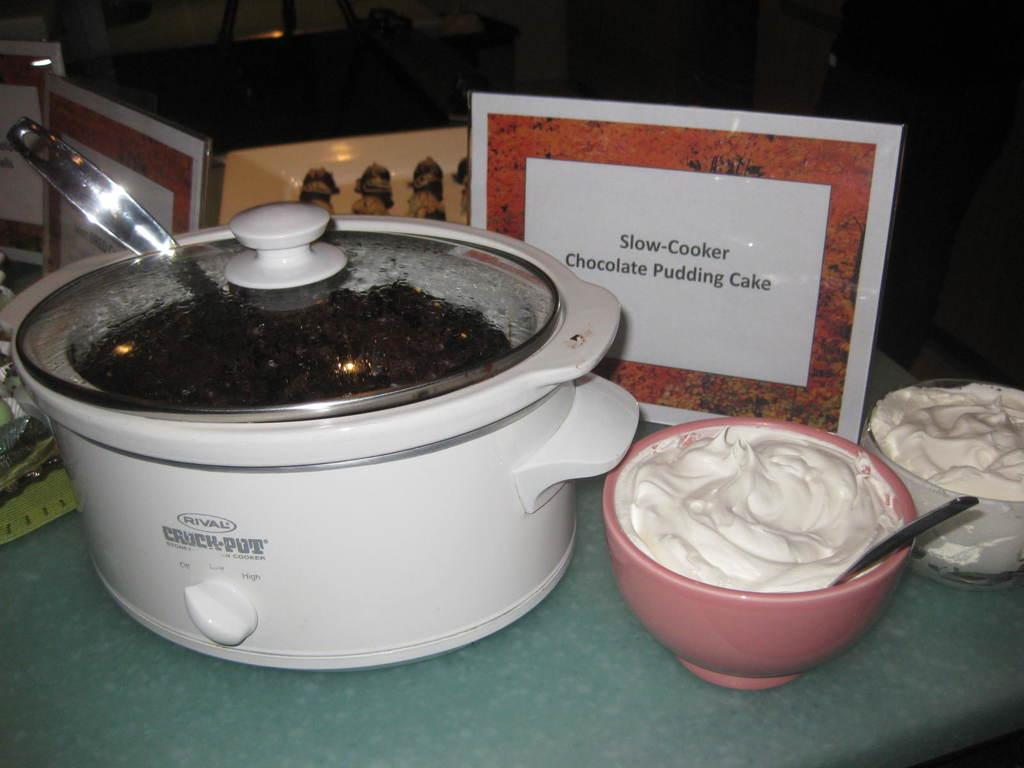<image>
Offer a succinct explanation of the picture presented. A crockpot full of slow-cooker chocolate pudding cake with a bowl of whip cream sitting next to it. 